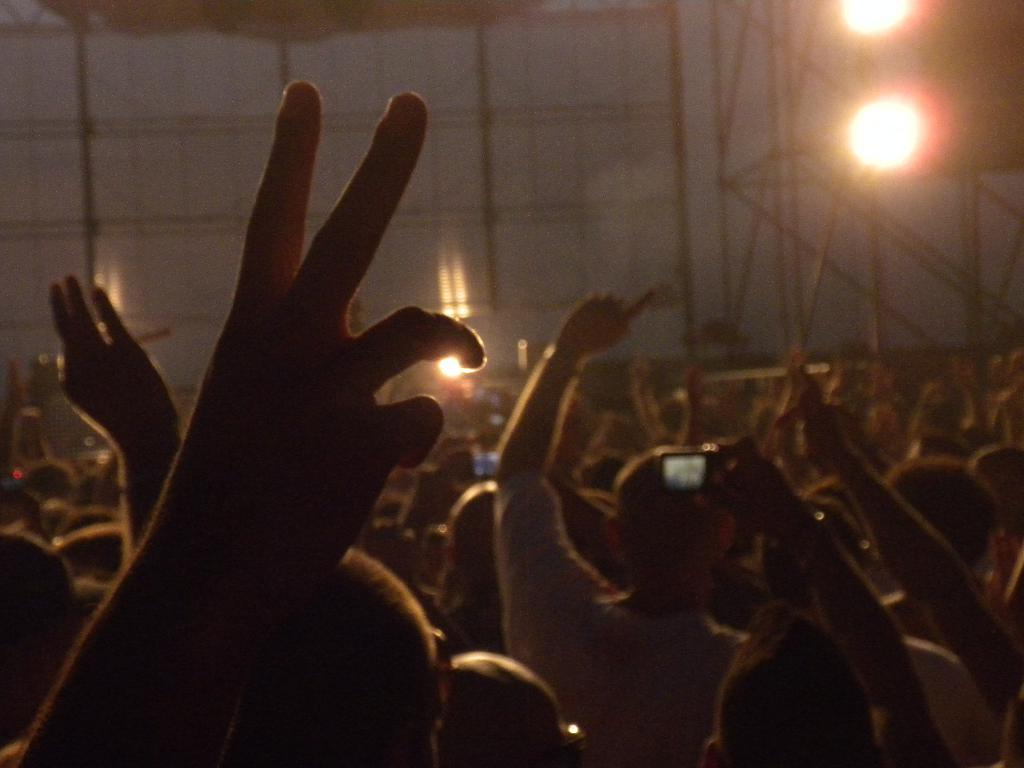What are the people in the image doing with their hands? The people in the image are raising their hands. Who is holding a camera in the image? There is a person holding a camera in the image. What can be seen in the background of the image? Lights are visible in the background of the image. Can you describe any objects in the background that might be made of metal? There may be metal rods in the background of the image. What color is the sweater worn by the person holding the camera in the image? There is no information about a sweater or its color in the image. Why are the people in the image crying? There is no indication that the people in the image are crying; they are raising their hands. 